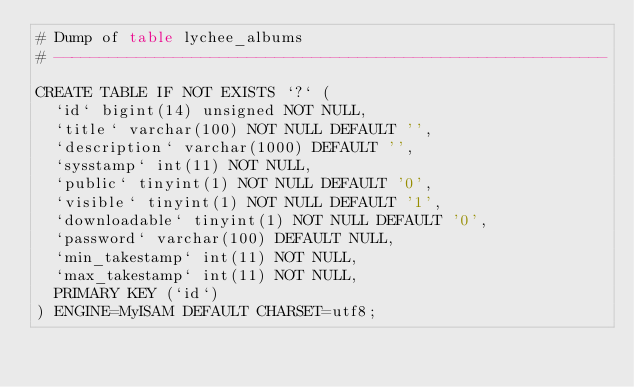Convert code to text. <code><loc_0><loc_0><loc_500><loc_500><_SQL_># Dump of table lychee_albums
# ------------------------------------------------------------

CREATE TABLE IF NOT EXISTS `?` (
  `id` bigint(14) unsigned NOT NULL,
  `title` varchar(100) NOT NULL DEFAULT '',
  `description` varchar(1000) DEFAULT '',
  `sysstamp` int(11) NOT NULL,
  `public` tinyint(1) NOT NULL DEFAULT '0',
  `visible` tinyint(1) NOT NULL DEFAULT '1',
  `downloadable` tinyint(1) NOT NULL DEFAULT '0',
  `password` varchar(100) DEFAULT NULL,
  `min_takestamp` int(11) NOT NULL,
  `max_takestamp` int(11) NOT NULL,
  PRIMARY KEY (`id`)
) ENGINE=MyISAM DEFAULT CHARSET=utf8;</code> 